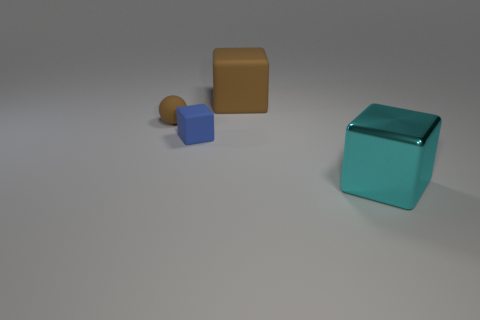What number of large objects are behind the tiny blue rubber object and to the right of the large brown matte thing?
Provide a succinct answer. 0. There is a block to the left of the large object behind the large cyan thing; what is its material?
Ensure brevity in your answer.  Rubber. Is there a blue block that has the same material as the tiny brown sphere?
Make the answer very short. Yes. There is a block that is the same size as the cyan shiny object; what is it made of?
Your answer should be compact. Rubber. There is a block that is in front of the block to the left of the big block that is on the left side of the cyan block; what is its size?
Keep it short and to the point. Large. There is a matte thing that is behind the ball; is there a brown rubber cube behind it?
Your answer should be very brief. No. Does the small brown matte object have the same shape as the object that is to the right of the brown cube?
Provide a succinct answer. No. What is the color of the block behind the tiny brown sphere?
Ensure brevity in your answer.  Brown. What size is the brown rubber thing in front of the brown thing behind the brown rubber sphere?
Make the answer very short. Small. Is the shape of the big thing behind the large metal thing the same as  the cyan object?
Offer a very short reply. Yes. 